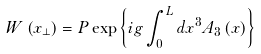Convert formula to latex. <formula><loc_0><loc_0><loc_500><loc_500>W \left ( x _ { \perp } \right ) = P \exp \left \{ i g \int _ { 0 } ^ { L } d x ^ { 3 } A _ { 3 } \left ( x \right ) \right \}</formula> 